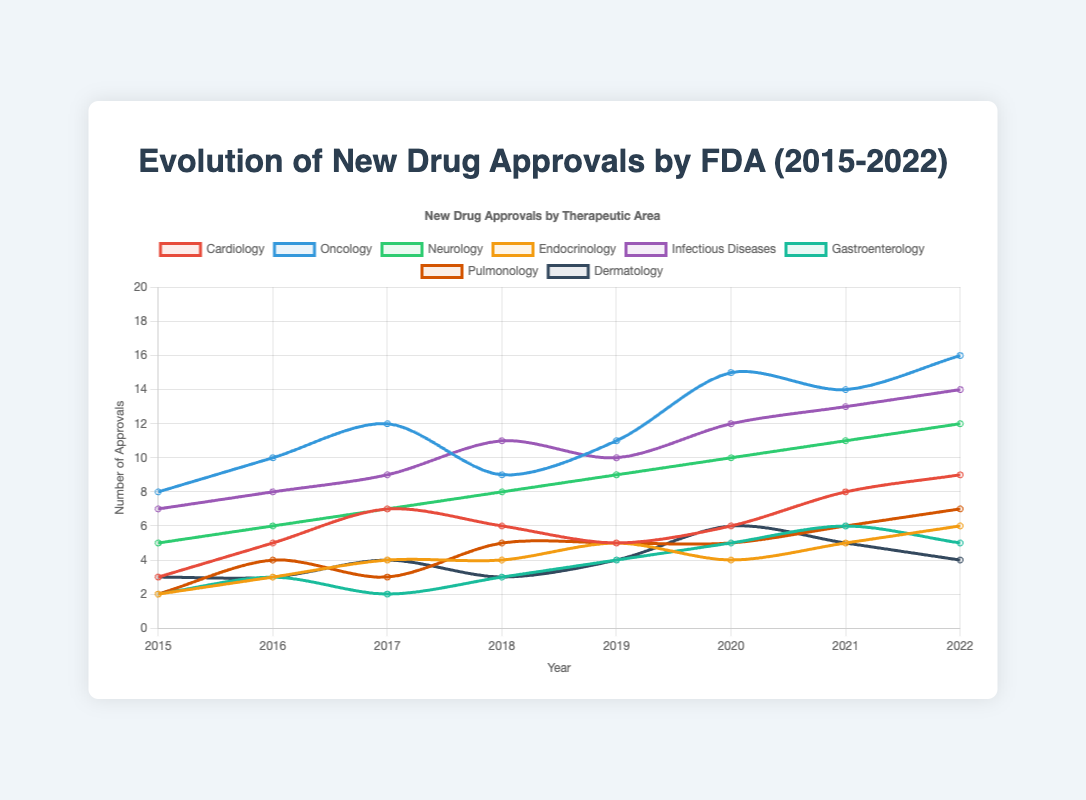What year did Neurology see the highest number of new drug approvals? To determine this, look at the Neurology line on the chart and find the year where the value is highest. In this case, Neurology shows the highest number in 2022 with 12 approvals.
Answer: 2022 Which therapeutic area had the most new drug approvals in 2021? Check the data points for all the therapeutic areas in the year 2021. Oncology had the highest number with 14 approvals.
Answer: Oncology How many new drug approvals were there in 2019 for Endocrinology and Gastroenterology combined? Add the Endocrinology approvals in 2019 (5) to the Gastroenterology approvals in 2019 (4). 5 + 4 = 9.
Answer: 9 Between 2016 and 2018, which therapeutic area showed the greatest fluctuation in new drug approvals? Check the changes in approval numbers year by year for each therapeutic area within the given years. Oncology, which went from 10 (2016) to 12 (2017) and then dropped to 9 (2018), presents the greatest fluctuation.
Answer: Oncology In which year did Cardiology and Pulmonology see the same number of new drug approvals? Look for a year where the lines representing Cardiology and Pulmonology intersect or have the same value. Both therapeutic areas had 5 new drug approvals in 2019.
Answer: 2019 What was the difference in new drug approvals between Infectious Diseases and Dermatology in 2020? Subtract the number of Dermatology approvals (6) from Infectious Diseases approvals (12) for 2020. 12 - 6 = 6.
Answer: 6 Compare the trends of Oncology and Neurology from 2016 to 2019. Both trends are increasing, but the rate of increase for Oncology is higher. Oncology goes from 10 in 2016 to 11 in 2019, while Neurology goes from 6 to 9 in the same period. This shows Oncology had a greater and faster growth than Neurology.
Answer: Oncology had a faster growth What was the average number of new drug approvals per year for Infectious Diseases between 2015 and 2022? Add up the number of new drug approvals for Infectious Diseases from 2015 to 2022 (7 + 8 + 9 + 11 + 10 + 12 + 13 + 14 = 84) and divide by the number of years (8). 84 / 8 = 10.5.
Answer: 10.5 